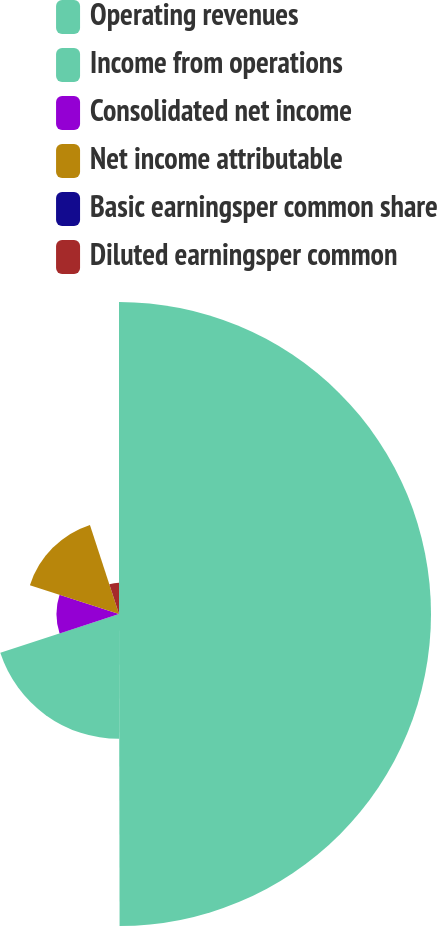Convert chart. <chart><loc_0><loc_0><loc_500><loc_500><pie_chart><fcel>Operating revenues<fcel>Income from operations<fcel>Consolidated net income<fcel>Net income attributable<fcel>Basic earningsper common share<fcel>Diluted earningsper common<nl><fcel>49.97%<fcel>20.0%<fcel>10.01%<fcel>15.0%<fcel>0.01%<fcel>5.01%<nl></chart> 